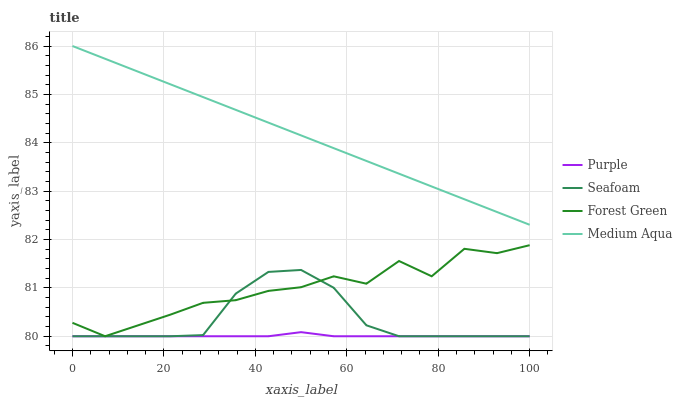Does Purple have the minimum area under the curve?
Answer yes or no. Yes. Does Medium Aqua have the maximum area under the curve?
Answer yes or no. Yes. Does Forest Green have the minimum area under the curve?
Answer yes or no. No. Does Forest Green have the maximum area under the curve?
Answer yes or no. No. Is Medium Aqua the smoothest?
Answer yes or no. Yes. Is Forest Green the roughest?
Answer yes or no. Yes. Is Forest Green the smoothest?
Answer yes or no. No. Is Medium Aqua the roughest?
Answer yes or no. No. Does Purple have the lowest value?
Answer yes or no. Yes. Does Medium Aqua have the lowest value?
Answer yes or no. No. Does Medium Aqua have the highest value?
Answer yes or no. Yes. Does Forest Green have the highest value?
Answer yes or no. No. Is Purple less than Medium Aqua?
Answer yes or no. Yes. Is Medium Aqua greater than Seafoam?
Answer yes or no. Yes. Does Forest Green intersect Seafoam?
Answer yes or no. Yes. Is Forest Green less than Seafoam?
Answer yes or no. No. Is Forest Green greater than Seafoam?
Answer yes or no. No. Does Purple intersect Medium Aqua?
Answer yes or no. No. 